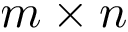Convert formula to latex. <formula><loc_0><loc_0><loc_500><loc_500>m \times n</formula> 